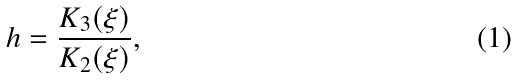<formula> <loc_0><loc_0><loc_500><loc_500>h = \frac { K _ { 3 } ( \xi ) } { K _ { 2 } ( \xi ) } ,</formula> 